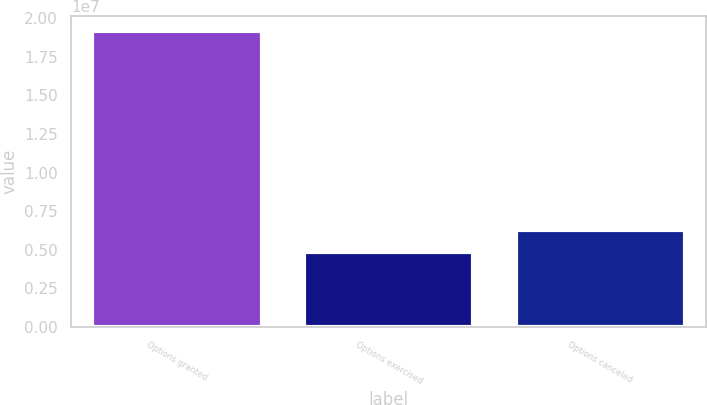Convert chart. <chart><loc_0><loc_0><loc_500><loc_500><bar_chart><fcel>Options granted<fcel>Options exercised<fcel>Options canceled<nl><fcel>1.91773e+07<fcel>4.82682e+06<fcel>6.26187e+06<nl></chart> 